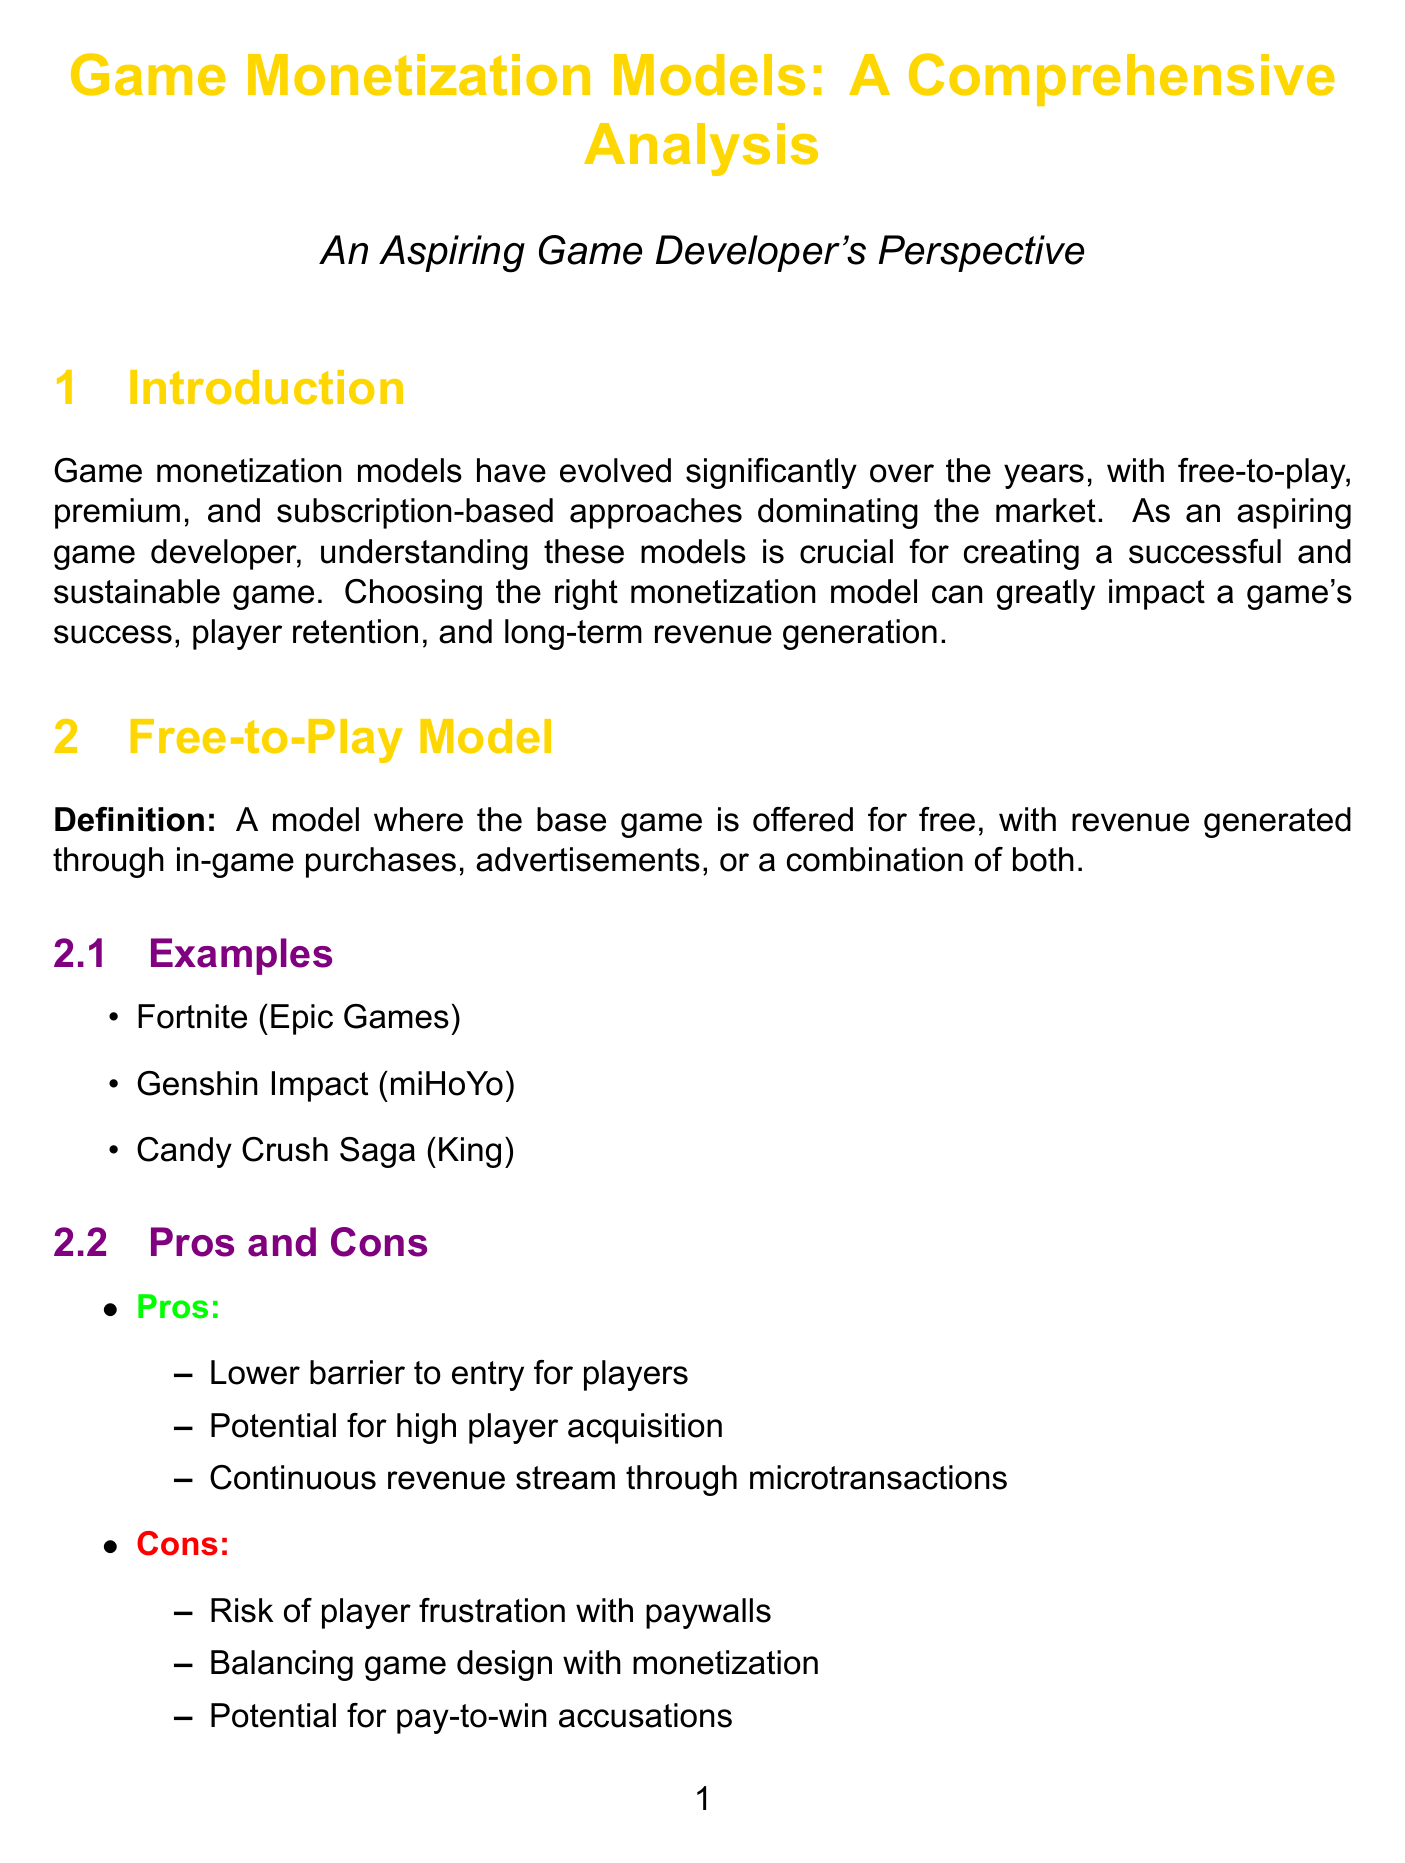What are the three main monetization models discussed? The document outlines three main models: free-to-play, premium, and subscription-based.
Answer: free-to-play, premium, subscription-based What is an example of a free-to-play game? The document lists Fortnite, Genshin Impact, and Candy Crush Saga as examples.
Answer: Fortnite What is a significant pro of the premium model? The document states that the premium model allows for upfront revenue generation.
Answer: Upfront revenue generation Which game is cited as a successful free-to-play example? The case study section names League of Legends as a successful example of the free-to-play model.
Answer: League of Legends What genre is associated with subscription-based games? The document mentions MMORPGs as a genre related to the subscription-based model.
Answer: MMORPGs What key factor contributed to the success of Final Fantasy XIV? The document highlights regular major content updates as a key factor for the success of Final Fantasy XIV.
Answer: Regular major content updates What should aspiring developers consider regarding market trends? Developers should stay informed about current market trends and player preferences in monetization.
Answer: Current market trends What is the primary focus of hybrid monetization models? The document states that hybrid models aim to maximize revenue potential through a combination of monetization strategies.
Answer: Maximize revenue potential What advice is given for aspiring game developers in choosing monetization models? The document advises developers to carefully consider which monetization model aligns best with their vision and player experience goals.
Answer: Align with vision and player experience goals 